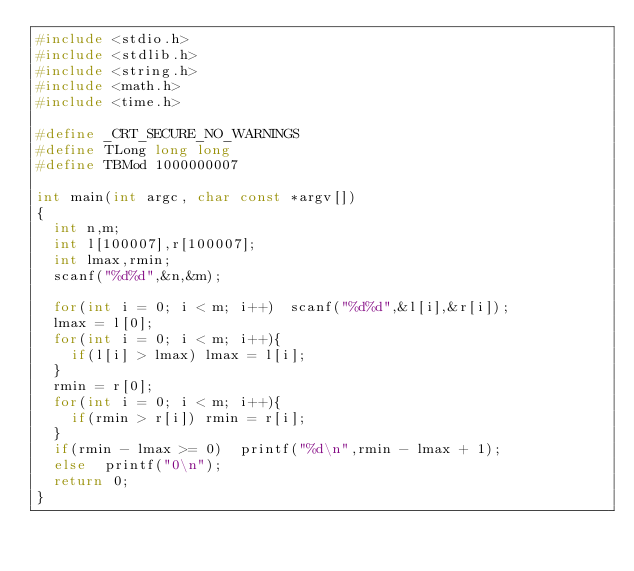Convert code to text. <code><loc_0><loc_0><loc_500><loc_500><_C_>#include <stdio.h>
#include <stdlib.h>
#include <string.h>
#include <math.h>
#include <time.h>

#define _CRT_SECURE_NO_WARNINGS
#define TLong long long
#define TBMod 1000000007

int main(int argc, char const *argv[])
{
	int n,m;
	int l[100007],r[100007];
	int lmax,rmin;
	scanf("%d%d",&n,&m);

	for(int i = 0; i < m; i++)	scanf("%d%d",&l[i],&r[i]);
	lmax = l[0];
	for(int i = 0; i < m; i++){
		if(l[i] > lmax)	lmax = l[i];
	}
	rmin = r[0];
	for(int i = 0; i < m; i++){
		if(rmin > r[i])	rmin = r[i];
	}	
	if(rmin - lmax >= 0)	printf("%d\n",rmin - lmax + 1);
	else	printf("0\n");
	return 0;
}
</code> 